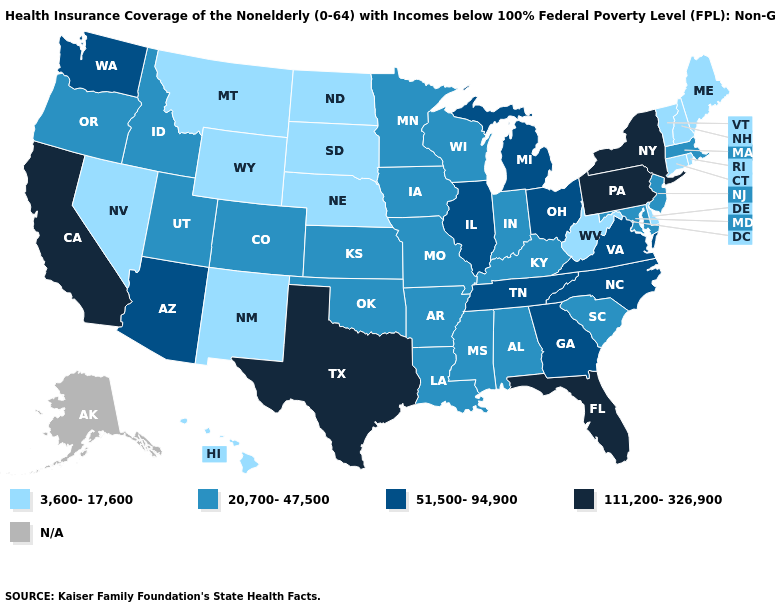How many symbols are there in the legend?
Answer briefly. 5. How many symbols are there in the legend?
Answer briefly. 5. What is the lowest value in states that border Tennessee?
Quick response, please. 20,700-47,500. Name the states that have a value in the range 20,700-47,500?
Short answer required. Alabama, Arkansas, Colorado, Idaho, Indiana, Iowa, Kansas, Kentucky, Louisiana, Maryland, Massachusetts, Minnesota, Mississippi, Missouri, New Jersey, Oklahoma, Oregon, South Carolina, Utah, Wisconsin. Name the states that have a value in the range 111,200-326,900?
Short answer required. California, Florida, New York, Pennsylvania, Texas. What is the value of Maryland?
Quick response, please. 20,700-47,500. What is the lowest value in the South?
Answer briefly. 3,600-17,600. What is the highest value in the Northeast ?
Keep it brief. 111,200-326,900. Is the legend a continuous bar?
Short answer required. No. Which states have the lowest value in the MidWest?
Concise answer only. Nebraska, North Dakota, South Dakota. Which states have the highest value in the USA?
Answer briefly. California, Florida, New York, Pennsylvania, Texas. What is the value of Oklahoma?
Be succinct. 20,700-47,500. Does California have the highest value in the West?
Keep it brief. Yes. What is the value of New Hampshire?
Short answer required. 3,600-17,600. Name the states that have a value in the range 51,500-94,900?
Give a very brief answer. Arizona, Georgia, Illinois, Michigan, North Carolina, Ohio, Tennessee, Virginia, Washington. 